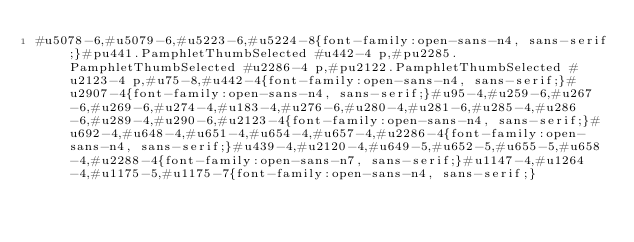Convert code to text. <code><loc_0><loc_0><loc_500><loc_500><_CSS_>#u5078-6,#u5079-6,#u5223-6,#u5224-8{font-family:open-sans-n4, sans-serif;}#pu441.PamphletThumbSelected #u442-4 p,#pu2285.PamphletThumbSelected #u2286-4 p,#pu2122.PamphletThumbSelected #u2123-4 p,#u75-8,#u442-4{font-family:open-sans-n4, sans-serif;}#u2907-4{font-family:open-sans-n4, sans-serif;}#u95-4,#u259-6,#u267-6,#u269-6,#u274-4,#u183-4,#u276-6,#u280-4,#u281-6,#u285-4,#u286-6,#u289-4,#u290-6,#u2123-4{font-family:open-sans-n4, sans-serif;}#u692-4,#u648-4,#u651-4,#u654-4,#u657-4,#u2286-4{font-family:open-sans-n4, sans-serif;}#u439-4,#u2120-4,#u649-5,#u652-5,#u655-5,#u658-4,#u2288-4{font-family:open-sans-n7, sans-serif;}#u1147-4,#u1264-4,#u1175-5,#u1175-7{font-family:open-sans-n4, sans-serif;}</code> 